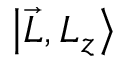<formula> <loc_0><loc_0><loc_500><loc_500>\left | { \vec { L } } , L _ { z } \right \rangle</formula> 